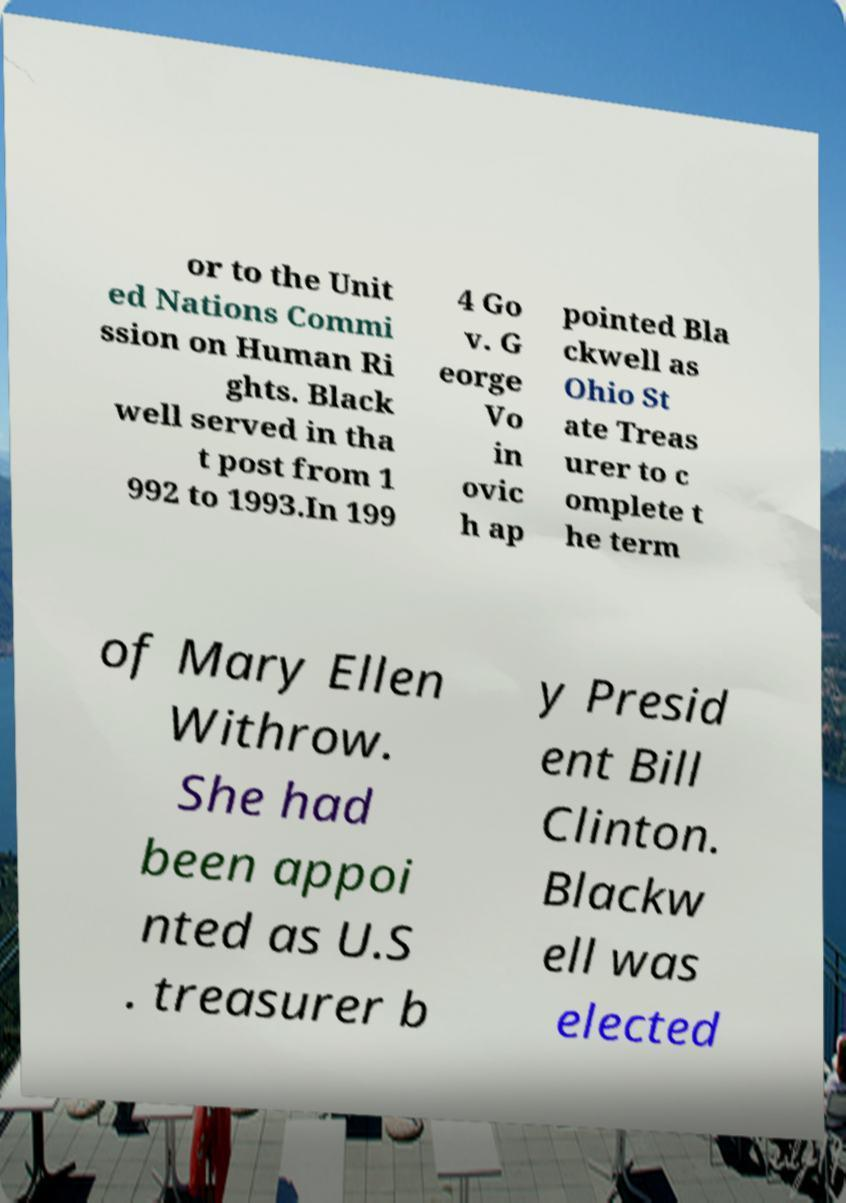Please read and relay the text visible in this image. What does it say? or to the Unit ed Nations Commi ssion on Human Ri ghts. Black well served in tha t post from 1 992 to 1993.In 199 4 Go v. G eorge Vo in ovic h ap pointed Bla ckwell as Ohio St ate Treas urer to c omplete t he term of Mary Ellen Withrow. She had been appoi nted as U.S . treasurer b y Presid ent Bill Clinton. Blackw ell was elected 